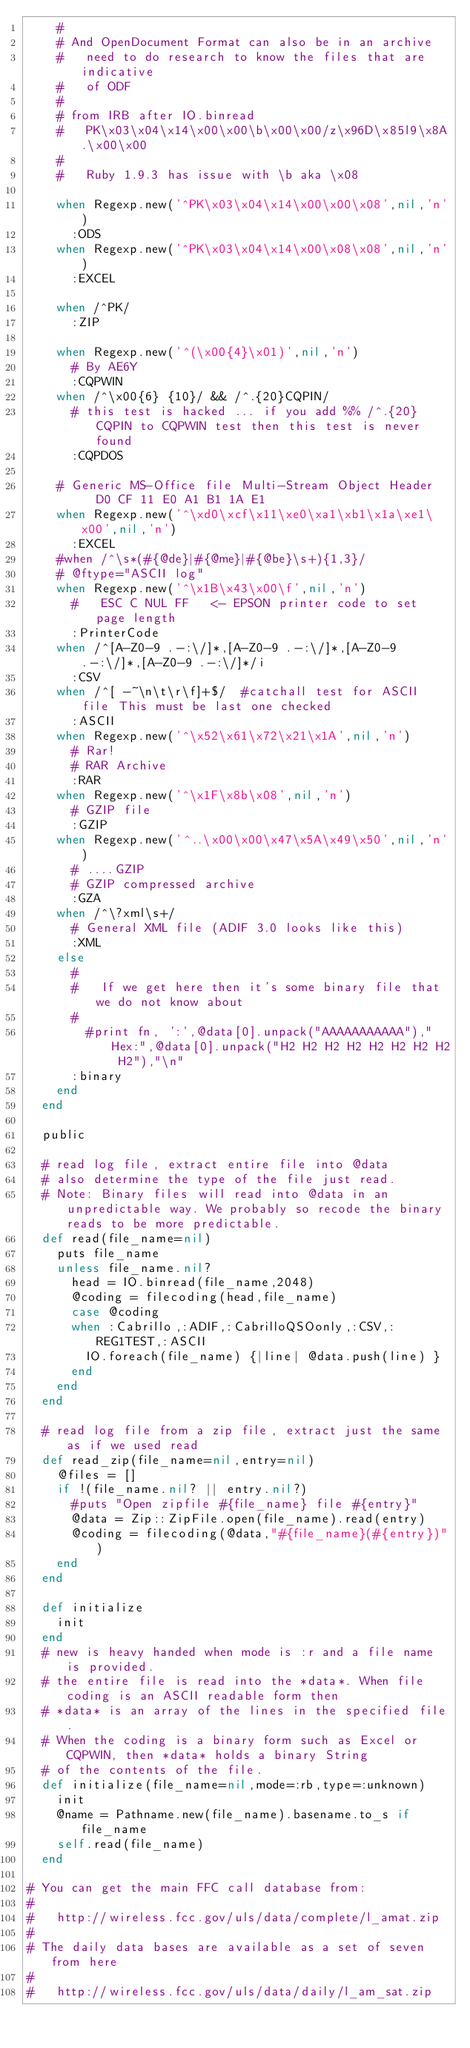Convert code to text. <code><loc_0><loc_0><loc_500><loc_500><_Ruby_>    #
    # And OpenDocument Format can also be in an archive
    #   need to do research to know the files that are indicative 
    #   of ODF
    #
    # from IRB after IO.binread
    #   PK\x03\x04\x14\x00\x00\b\x00\x00/z\x96D\x85l9\x8A.\x00\x00
    #
    #   Ruby 1.9.3 has issue with \b aka \x08
  
    when Regexp.new('^PK\x03\x04\x14\x00\x00\x08',nil,'n')
      :ODS
    when Regexp.new('^PK\x03\x04\x14\x00\x08\x08',nil,'n')
      :EXCEL
      
    when /^PK/
      :ZIP
      
    when Regexp.new('^(\x00{4}\x01)',nil,'n') 
      # By AE6Y
      :CQPWIN
    when /^\x00{6} {10}/ && /^.{20}CQPIN/
      # this test is hacked ... if you add %% /^.{20}CQPIN to CQPWIN test then this test is never found
      :CQPDOS
    
    # Generic MS-Office file Multi-Stream Object Header   D0 CF 11 E0 A1 B1 1A E1
    when Regexp.new('^\xd0\xcf\x11\xe0\xa1\xb1\x1a\xe1\x00',nil,'n')
      :EXCEL
    #when /^\s*(#{@de}|#{@me}|#{@be}\s+){1,3}/
    # @ftype="ASCII log"
    when Regexp.new('^\x1B\x43\x00\f',nil,'n')
      #   ESC C NUL FF   <- EPSON printer code to set page length
      :PrinterCode
    when /^[A-Z0-9 .-:\/]*,[A-Z0-9 .-:\/]*,[A-Z0-9 .-:\/]*,[A-Z0-9 .-:\/]*/i
      :CSV
    when /^[ -~\n\t\r\f]+$/  #catchall test for ASCII file This must be last one checked
      :ASCII
    when Regexp.new('^\x52\x61\x72\x21\x1A',nil,'n')
      # Rar!      
      # RAR Archive
      :RAR
    when Regexp.new('^\x1F\x8b\x08',nil,'n')
      # GZIP file
      :GZIP
    when Regexp.new('^..\x00\x00\x47\x5A\x49\x50',nil,'n')
      # ....GZIP
      # GZIP compressed archive
      :GZA
    when /^\?xml\s+/
      # General XML file (ADIF 3.0 looks like this)
      :XML
    else 
      #
      #   If we get here then it's some binary file that we do not know about
      #
        #print fn, ':',@data[0].unpack("AAAAAAAAAAA")," Hex:",@data[0].unpack("H2 H2 H2 H2 H2 H2 H2 H2 H2"),"\n"
      :binary
    end
  end
  
  public
  
  # read log file, extract entire file into @data
  # also determine the type of the file just read.
  # Note: Binary files will read into @data in an unpredictable way. We probably so recode the binary reads to be more predictable.
  def read(file_name=nil)
    puts file_name
    unless file_name.nil?
      head = IO.binread(file_name,2048)
      @coding = filecoding(head,file_name)
      case @coding
      when :Cabrillo,:ADIF,:CabrilloQSOonly,:CSV,:REG1TEST,:ASCII
        IO.foreach(file_name) {|line| @data.push(line) }
      end
    end
  end

  # read log file from a zip file, extract just the same as if we used read
  def read_zip(file_name=nil,entry=nil)
    @files = []
    if !(file_name.nil? || entry.nil?)
      #puts "Open zipfile #{file_name} file #{entry}"
      @data = Zip::ZipFile.open(file_name).read(entry)
      @coding = filecoding(@data,"#{file_name}(#{entry})")
    end
  end
  
  def initialize
    init
  end
  # new is heavy handed when mode is :r and a file name is provided.
  # the entire file is read into the *data*. When file coding is an ASCII readable form then
  # *data* is an array of the lines in the specified file.
  # When the coding is a binary form such as Excel or CQPWIN, then *data* holds a binary String
  # of the contents of the file.
  def initialize(file_name=nil,mode=:rb,type=:unknown)
    init
    @name = Pathname.new(file_name).basename.to_s if file_name
    self.read(file_name)
  end
  
# You can get the main FFC call database from: 
#
#   http://wireless.fcc.gov/uls/data/complete/l_amat.zip
#
# The daily data bases are available as a set of seven from here
#
#   http://wireless.fcc.gov/uls/data/daily/l_am_sat.zip </code> 